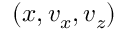Convert formula to latex. <formula><loc_0><loc_0><loc_500><loc_500>( x , v _ { x } , v _ { z } )</formula> 